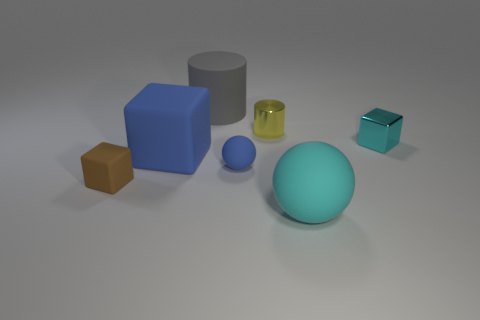What material is the big ball that is the same color as the metallic block?
Offer a terse response. Rubber. Is the size of the cyan metallic block the same as the blue cube that is right of the tiny brown object?
Your answer should be compact. No. How many things are either rubber balls in front of the blue sphere or blue things?
Keep it short and to the point. 3. What is the shape of the big thing that is right of the tiny shiny cylinder?
Make the answer very short. Sphere. Is the number of brown blocks right of the yellow metallic thing the same as the number of tiny blue rubber balls to the left of the blue rubber block?
Your answer should be very brief. Yes. The small thing that is to the right of the big gray object and in front of the small cyan metal block is what color?
Offer a very short reply. Blue. What is the material of the tiny block left of the rubber object to the right of the tiny sphere?
Provide a short and direct response. Rubber. Do the cyan matte object and the yellow cylinder have the same size?
Keep it short and to the point. No. What number of big objects are cyan balls or matte cylinders?
Ensure brevity in your answer.  2. There is a large cylinder; what number of tiny matte spheres are left of it?
Provide a short and direct response. 0. 